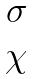Convert formula to latex. <formula><loc_0><loc_0><loc_500><loc_500>\begin{matrix} \sigma \\ \chi \end{matrix}</formula> 